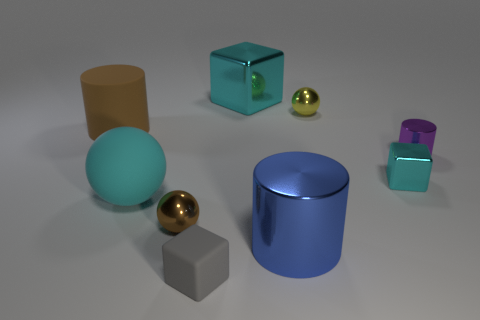Is there a matte cylinder that has the same color as the small metal cube?
Offer a terse response. No. There is a blue cylinder that is made of the same material as the purple object; what size is it?
Offer a very short reply. Large. Is the cyan sphere made of the same material as the yellow sphere?
Provide a succinct answer. No. What is the color of the cylinder left of the cyan metallic cube to the left of the small ball right of the matte cube?
Provide a short and direct response. Brown. The purple object has what shape?
Offer a terse response. Cylinder. There is a matte block; is its color the same as the big shiny object that is in front of the large block?
Provide a short and direct response. No. Is the number of small purple metallic things that are left of the blue cylinder the same as the number of big purple matte cylinders?
Keep it short and to the point. Yes. What number of blue shiny objects are the same size as the cyan matte object?
Offer a very short reply. 1. What shape is the large metal object that is the same color as the large rubber sphere?
Make the answer very short. Cube. Is there a matte cylinder?
Provide a short and direct response. Yes. 